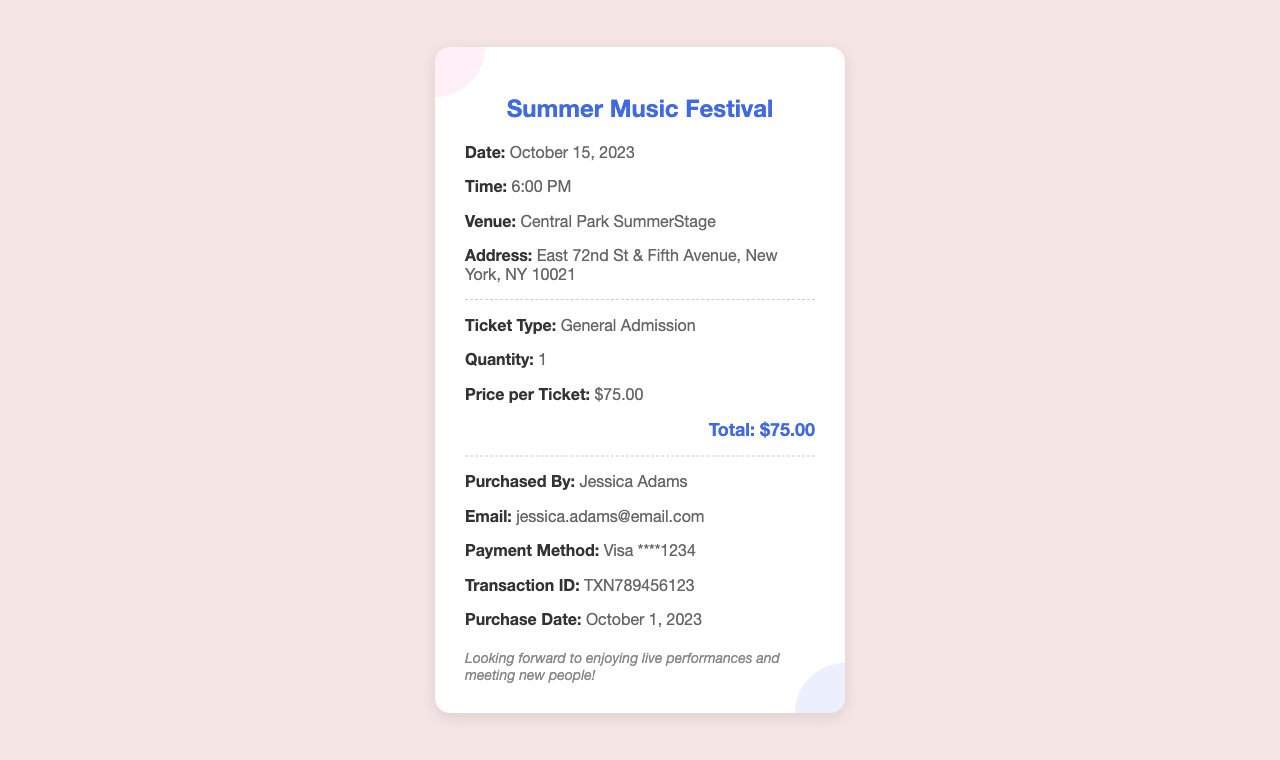What is the event date? The event date is specified in the document under "Date."
Answer: October 15, 2023 Where is the venue located? The location of the venue is provided in the document under "Venue."
Answer: Central Park SummerStage What is the ticket price? The price of the ticket can be found in the document under "Price per Ticket."
Answer: $75.00 Who purchased the ticket? The name of the person who purchased the ticket is given in the document under "Purchased By."
Answer: Jessica Adams What is the total amount paid? The total payment made for the ticket is mentioned at the bottom of the receipt.
Answer: $75.00 What type of ticket was purchased? The type of ticket can be found under the section labeled "Ticket Type."
Answer: General Admission What payment method was used? The payment method is specified in the document under "Payment Method."
Answer: Visa ****1234 What is the transaction ID? The unique identifier for the transaction is located in the document under "Transaction ID."
Answer: TXN789456123 When was the ticket purchased? The purchase date is clearly stated in the document under "Purchase Date."
Answer: October 1, 2023 